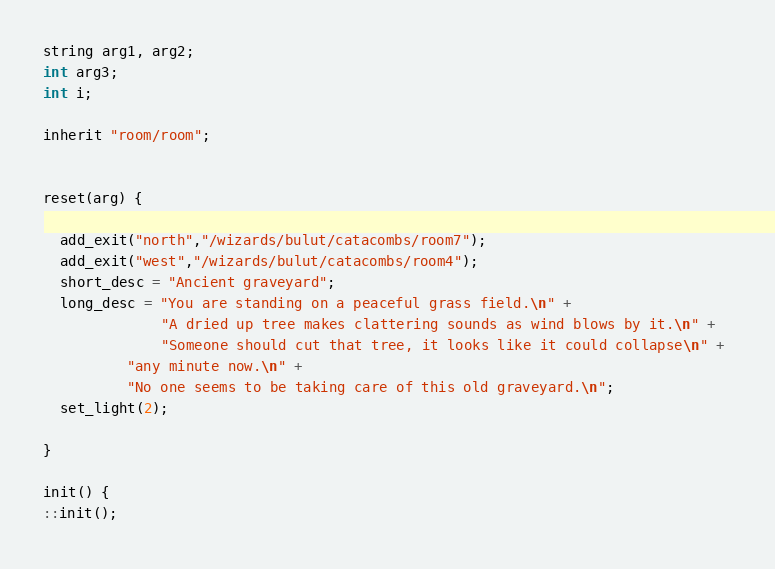<code> <loc_0><loc_0><loc_500><loc_500><_C_>string arg1, arg2;
int arg3;
int i;

inherit "room/room";


reset(arg) {

  add_exit("north","/wizards/bulut/catacombs/room7");
  add_exit("west","/wizards/bulut/catacombs/room4");
  short_desc = "Ancient graveyard";
  long_desc = "You are standing on a peaceful grass field.\n" +
              "A dried up tree makes clattering sounds as wind blows by it.\n" +  
              "Someone should cut that tree, it looks like it could collapse\n" +
	      "any minute now.\n" +
	      "No one seems to be taking care of this old graveyard.\n";
  set_light(2);                 
  
}

init() {
::init();</code> 